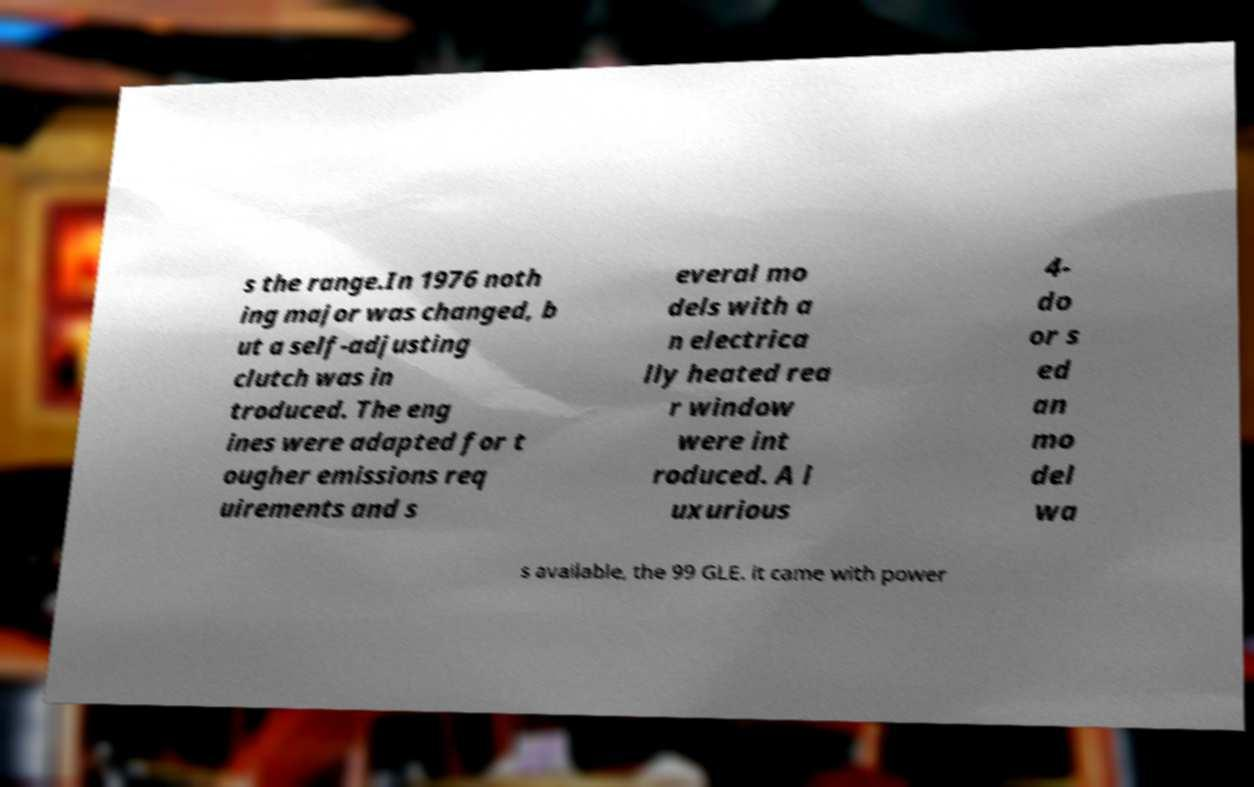Please read and relay the text visible in this image. What does it say? s the range.In 1976 noth ing major was changed, b ut a self-adjusting clutch was in troduced. The eng ines were adapted for t ougher emissions req uirements and s everal mo dels with a n electrica lly heated rea r window were int roduced. A l uxurious 4- do or s ed an mo del wa s available, the 99 GLE. it came with power 